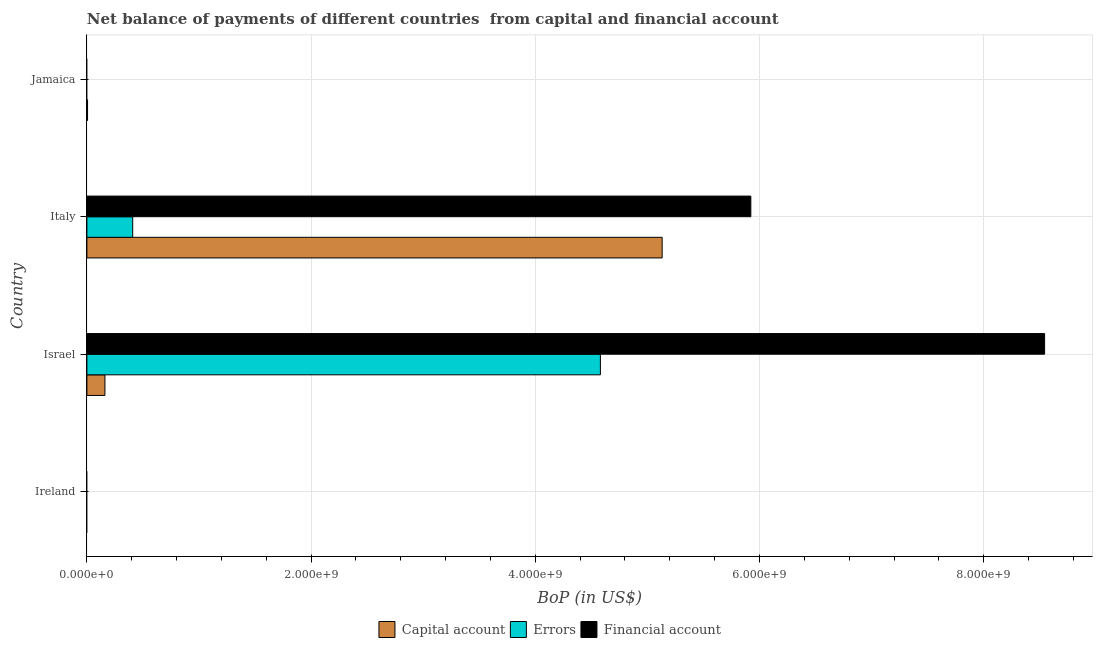How many different coloured bars are there?
Ensure brevity in your answer.  3. Are the number of bars on each tick of the Y-axis equal?
Offer a very short reply. No. In how many cases, is the number of bars for a given country not equal to the number of legend labels?
Provide a short and direct response. 2. What is the amount of errors in Italy?
Ensure brevity in your answer.  4.09e+08. Across all countries, what is the maximum amount of errors?
Make the answer very short. 4.58e+09. Across all countries, what is the minimum amount of financial account?
Your response must be concise. 0. What is the total amount of errors in the graph?
Provide a succinct answer. 4.99e+09. What is the difference between the amount of financial account in Israel and that in Italy?
Your response must be concise. 2.62e+09. What is the difference between the amount of errors in Jamaica and the amount of net capital account in Israel?
Make the answer very short. -1.61e+08. What is the average amount of financial account per country?
Provide a short and direct response. 3.62e+09. What is the difference between the amount of net capital account and amount of errors in Israel?
Offer a very short reply. -4.42e+09. In how many countries, is the amount of net capital account greater than 6400000000 US$?
Provide a succinct answer. 0. Is the amount of financial account in Israel less than that in Italy?
Keep it short and to the point. No. What is the difference between the highest and the second highest amount of net capital account?
Offer a terse response. 4.97e+09. What is the difference between the highest and the lowest amount of errors?
Ensure brevity in your answer.  4.58e+09. In how many countries, is the amount of financial account greater than the average amount of financial account taken over all countries?
Offer a very short reply. 2. How many bars are there?
Make the answer very short. 7. Does the graph contain any zero values?
Offer a terse response. Yes. How many legend labels are there?
Ensure brevity in your answer.  3. What is the title of the graph?
Your response must be concise. Net balance of payments of different countries  from capital and financial account. What is the label or title of the X-axis?
Give a very brief answer. BoP (in US$). What is the label or title of the Y-axis?
Provide a succinct answer. Country. What is the BoP (in US$) of Capital account in Ireland?
Make the answer very short. 0. What is the BoP (in US$) of Capital account in Israel?
Your answer should be compact. 1.61e+08. What is the BoP (in US$) in Errors in Israel?
Provide a short and direct response. 4.58e+09. What is the BoP (in US$) of Financial account in Israel?
Offer a very short reply. 8.54e+09. What is the BoP (in US$) in Capital account in Italy?
Give a very brief answer. 5.13e+09. What is the BoP (in US$) in Errors in Italy?
Provide a succinct answer. 4.09e+08. What is the BoP (in US$) in Financial account in Italy?
Provide a succinct answer. 5.92e+09. What is the BoP (in US$) in Capital account in Jamaica?
Your response must be concise. 5.87e+06. What is the BoP (in US$) in Errors in Jamaica?
Keep it short and to the point. 0. Across all countries, what is the maximum BoP (in US$) in Capital account?
Give a very brief answer. 5.13e+09. Across all countries, what is the maximum BoP (in US$) of Errors?
Your answer should be compact. 4.58e+09. Across all countries, what is the maximum BoP (in US$) of Financial account?
Keep it short and to the point. 8.54e+09. Across all countries, what is the minimum BoP (in US$) in Financial account?
Keep it short and to the point. 0. What is the total BoP (in US$) of Capital account in the graph?
Ensure brevity in your answer.  5.30e+09. What is the total BoP (in US$) of Errors in the graph?
Provide a short and direct response. 4.99e+09. What is the total BoP (in US$) of Financial account in the graph?
Give a very brief answer. 1.45e+1. What is the difference between the BoP (in US$) in Capital account in Israel and that in Italy?
Keep it short and to the point. -4.97e+09. What is the difference between the BoP (in US$) of Errors in Israel and that in Italy?
Make the answer very short. 4.17e+09. What is the difference between the BoP (in US$) in Financial account in Israel and that in Italy?
Keep it short and to the point. 2.62e+09. What is the difference between the BoP (in US$) in Capital account in Israel and that in Jamaica?
Your response must be concise. 1.55e+08. What is the difference between the BoP (in US$) in Capital account in Italy and that in Jamaica?
Offer a terse response. 5.13e+09. What is the difference between the BoP (in US$) in Capital account in Israel and the BoP (in US$) in Errors in Italy?
Offer a very short reply. -2.48e+08. What is the difference between the BoP (in US$) of Capital account in Israel and the BoP (in US$) of Financial account in Italy?
Ensure brevity in your answer.  -5.76e+09. What is the difference between the BoP (in US$) in Errors in Israel and the BoP (in US$) in Financial account in Italy?
Your response must be concise. -1.34e+09. What is the average BoP (in US$) of Capital account per country?
Keep it short and to the point. 1.32e+09. What is the average BoP (in US$) of Errors per country?
Give a very brief answer. 1.25e+09. What is the average BoP (in US$) of Financial account per country?
Keep it short and to the point. 3.62e+09. What is the difference between the BoP (in US$) of Capital account and BoP (in US$) of Errors in Israel?
Offer a terse response. -4.42e+09. What is the difference between the BoP (in US$) of Capital account and BoP (in US$) of Financial account in Israel?
Your answer should be compact. -8.38e+09. What is the difference between the BoP (in US$) of Errors and BoP (in US$) of Financial account in Israel?
Provide a short and direct response. -3.96e+09. What is the difference between the BoP (in US$) in Capital account and BoP (in US$) in Errors in Italy?
Provide a succinct answer. 4.72e+09. What is the difference between the BoP (in US$) of Capital account and BoP (in US$) of Financial account in Italy?
Your answer should be very brief. -7.91e+08. What is the difference between the BoP (in US$) in Errors and BoP (in US$) in Financial account in Italy?
Your answer should be compact. -5.51e+09. What is the ratio of the BoP (in US$) of Capital account in Israel to that in Italy?
Your answer should be very brief. 0.03. What is the ratio of the BoP (in US$) of Errors in Israel to that in Italy?
Ensure brevity in your answer.  11.21. What is the ratio of the BoP (in US$) of Financial account in Israel to that in Italy?
Make the answer very short. 1.44. What is the ratio of the BoP (in US$) in Capital account in Israel to that in Jamaica?
Keep it short and to the point. 27.39. What is the ratio of the BoP (in US$) of Capital account in Italy to that in Jamaica?
Make the answer very short. 874. What is the difference between the highest and the second highest BoP (in US$) in Capital account?
Keep it short and to the point. 4.97e+09. What is the difference between the highest and the lowest BoP (in US$) in Capital account?
Your answer should be compact. 5.13e+09. What is the difference between the highest and the lowest BoP (in US$) in Errors?
Offer a very short reply. 4.58e+09. What is the difference between the highest and the lowest BoP (in US$) in Financial account?
Give a very brief answer. 8.54e+09. 